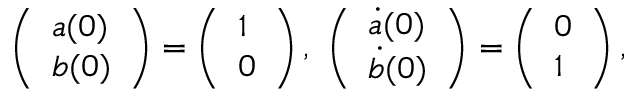Convert formula to latex. <formula><loc_0><loc_0><loc_500><loc_500>\left ( \begin{array} { l } { a ( 0 ) } \\ { { b } ( 0 ) } \end{array} \right ) = \left ( \begin{array} { l } { 1 } \\ { 0 } \end{array} \right ) , \ \left ( \begin{array} { l } { \dot { a } ( 0 ) } \\ { \dot { b } ( 0 ) } \end{array} \right ) = \left ( \begin{array} { l } { 0 } \\ { 1 } \end{array} \right ) ,</formula> 